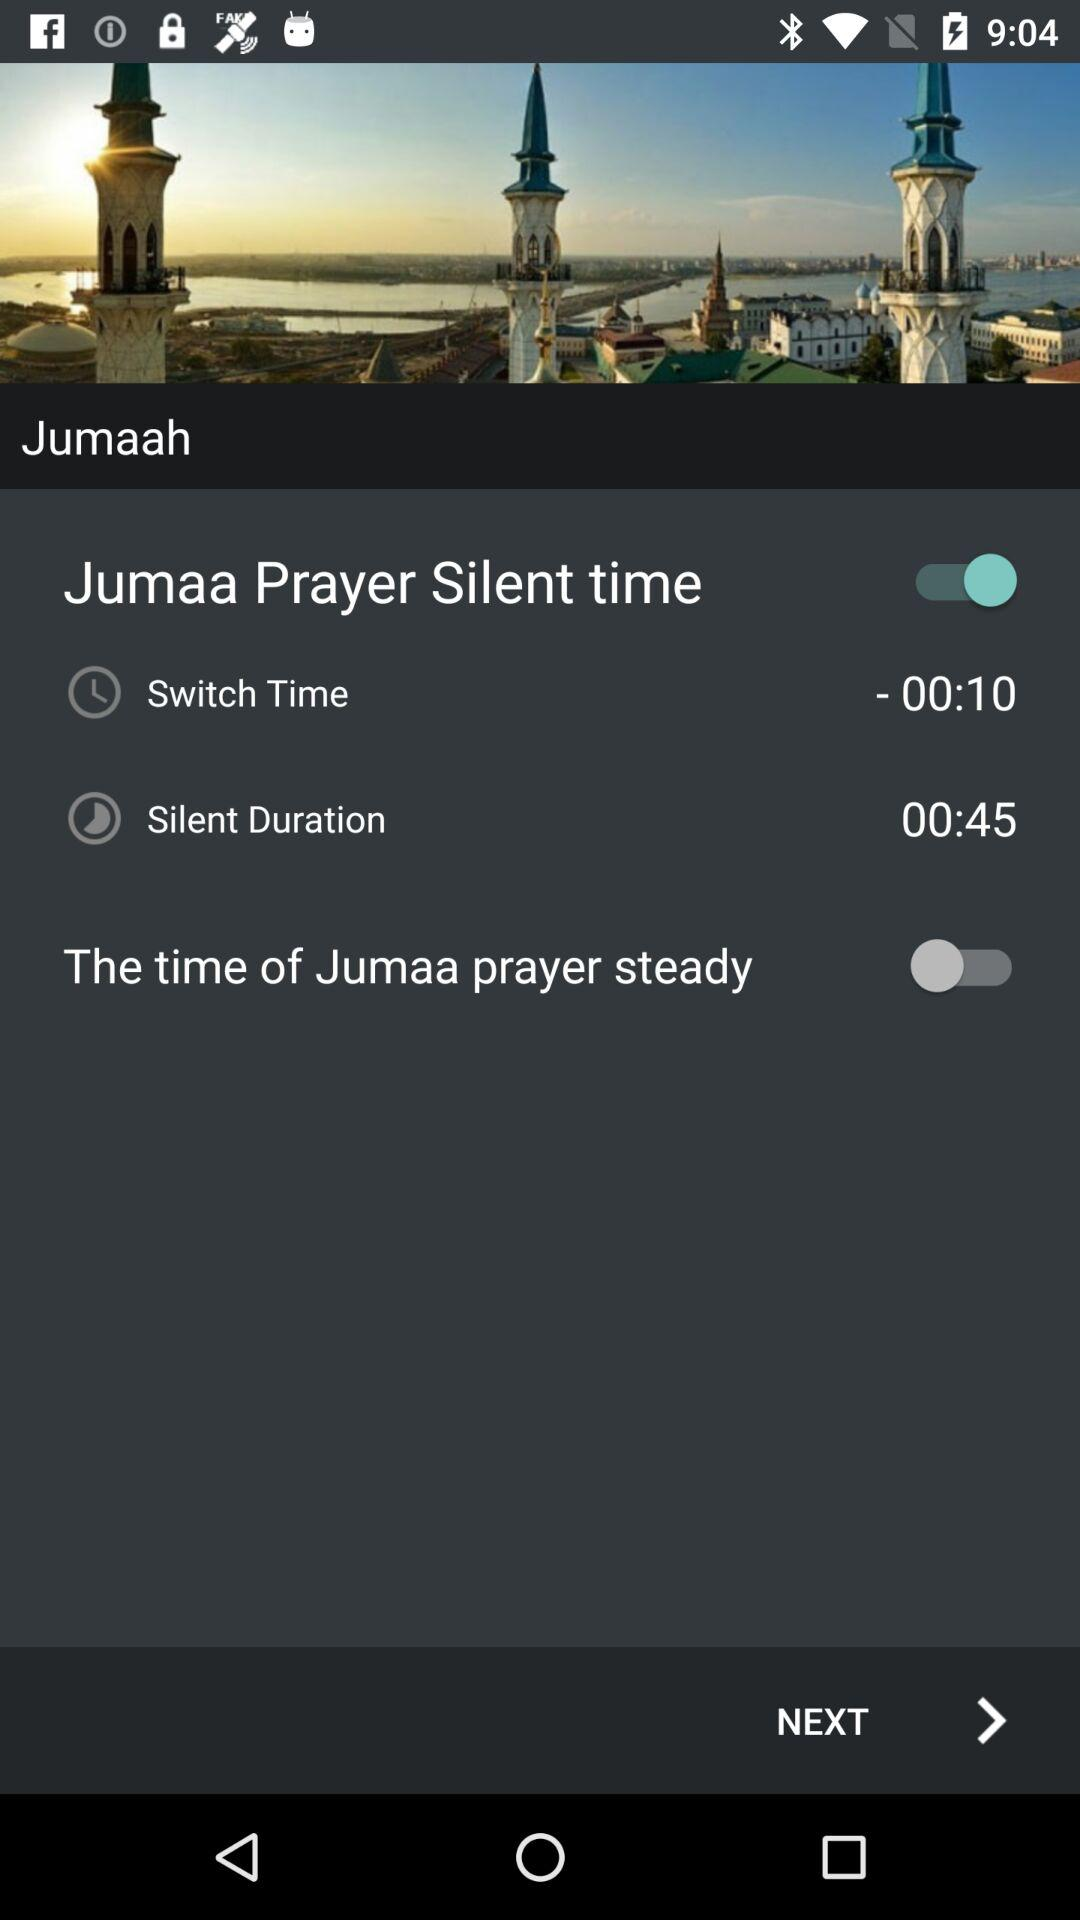What is the switch time for "Jumaa Prayer Silent time"? The switch time is 00:10. 